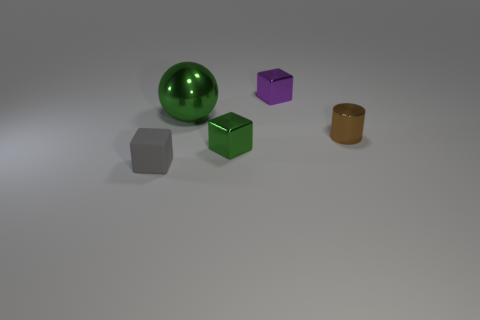Are there any tiny gray objects?
Give a very brief answer. Yes. There is a large metallic sphere; does it have the same color as the small shiny cube in front of the purple block?
Ensure brevity in your answer.  Yes. Are there any other things that are the same shape as the brown metallic object?
Your answer should be compact. No. The big green metallic thing left of the metal block behind the green thing in front of the large metallic object is what shape?
Make the answer very short. Sphere. What is the shape of the large green metal thing?
Make the answer very short. Sphere. The small object in front of the small green thing is what color?
Your answer should be very brief. Gray. There is a green metal thing that is in front of the brown cylinder; does it have the same size as the big green metal sphere?
Ensure brevity in your answer.  No. The other green thing that is the same shape as the matte thing is what size?
Your answer should be very brief. Small. Are there any other things that have the same size as the sphere?
Make the answer very short. No. Is the large object the same shape as the small green metallic object?
Offer a very short reply. No. 